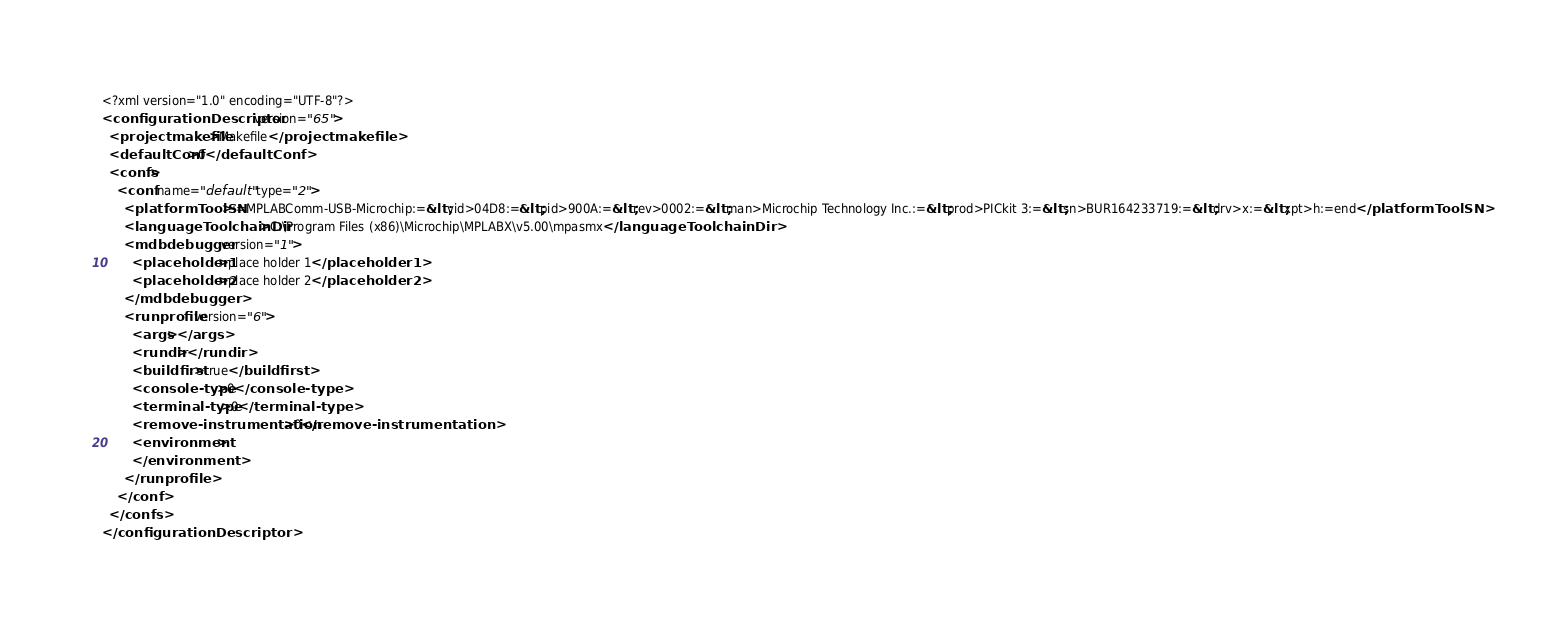<code> <loc_0><loc_0><loc_500><loc_500><_XML_><?xml version="1.0" encoding="UTF-8"?>
<configurationDescriptor version="65">
  <projectmakefile>Makefile</projectmakefile>
  <defaultConf>0</defaultConf>
  <confs>
    <conf name="default" type="2">
      <platformToolSN>:=MPLABComm-USB-Microchip:=&lt;vid>04D8:=&lt;pid>900A:=&lt;rev>0002:=&lt;man>Microchip Technology Inc.:=&lt;prod>PICkit 3:=&lt;sn>BUR164233719:=&lt;drv>x:=&lt;xpt>h:=end</platformToolSN>
      <languageToolchainDir>C:\Program Files (x86)\Microchip\MPLABX\v5.00\mpasmx</languageToolchainDir>
      <mdbdebugger version="1">
        <placeholder1>place holder 1</placeholder1>
        <placeholder2>place holder 2</placeholder2>
      </mdbdebugger>
      <runprofile version="6">
        <args></args>
        <rundir></rundir>
        <buildfirst>true</buildfirst>
        <console-type>0</console-type>
        <terminal-type>0</terminal-type>
        <remove-instrumentation>0</remove-instrumentation>
        <environment>
        </environment>
      </runprofile>
    </conf>
  </confs>
</configurationDescriptor>
</code> 